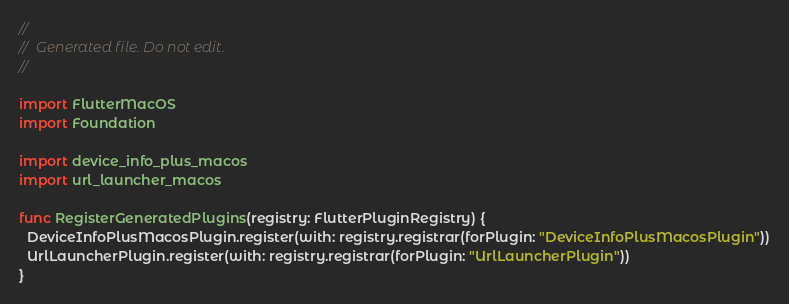<code> <loc_0><loc_0><loc_500><loc_500><_Swift_>//
//  Generated file. Do not edit.
//

import FlutterMacOS
import Foundation

import device_info_plus_macos
import url_launcher_macos

func RegisterGeneratedPlugins(registry: FlutterPluginRegistry) {
  DeviceInfoPlusMacosPlugin.register(with: registry.registrar(forPlugin: "DeviceInfoPlusMacosPlugin"))
  UrlLauncherPlugin.register(with: registry.registrar(forPlugin: "UrlLauncherPlugin"))
}
</code> 